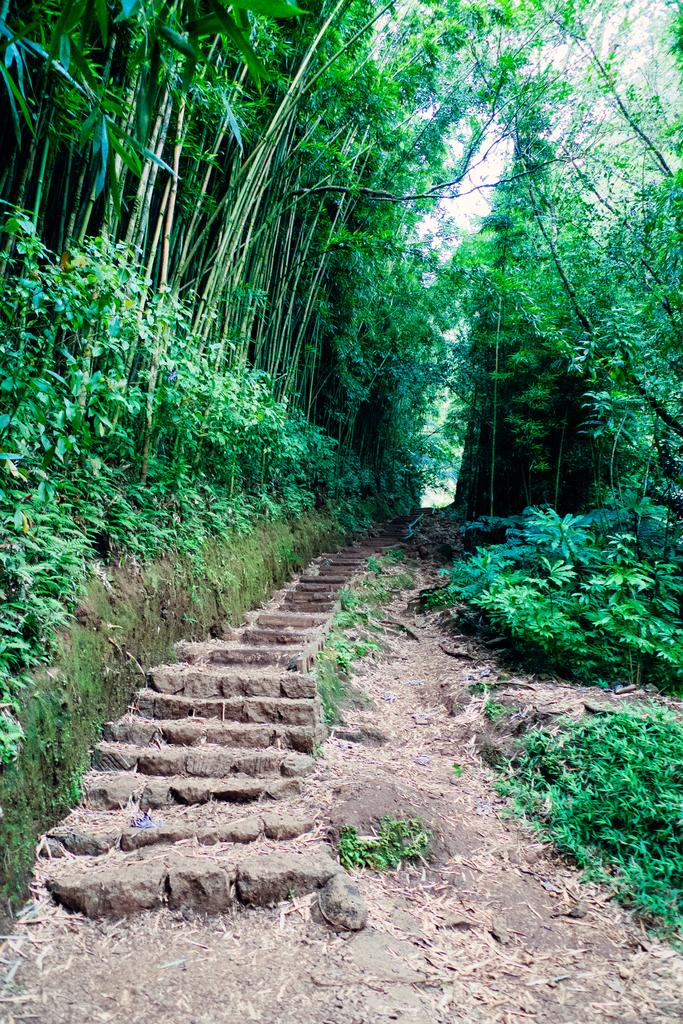What is located in the middle of the image? There are trees in the middle of the image. What can be seen in the background of the image? The sky is visible in the background of the image. What architectural feature is present at the bottom of the image? There are stairs at the bottom of the image. What type of wren can be seen flying around the trees in the image? There is no wren present in the image; it only features trees and stairs. Is there a net used to catch the wren in the image? There is no wren or net present in the image. 